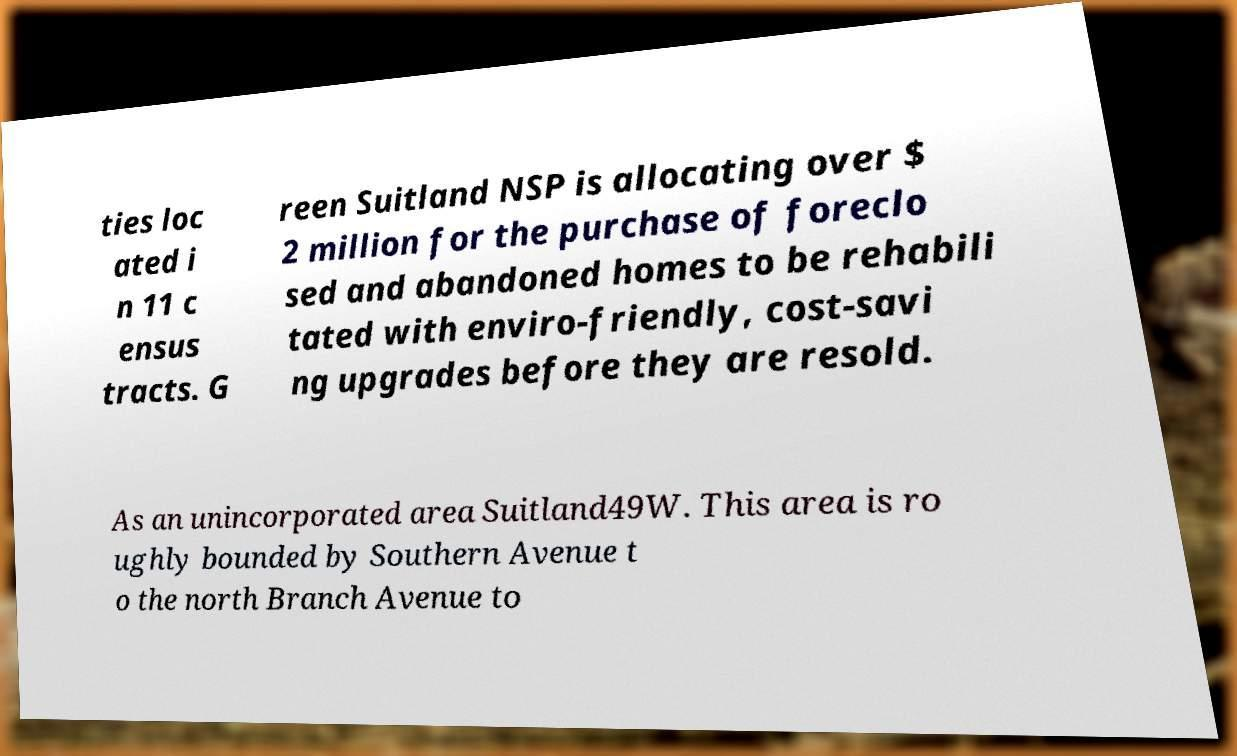Could you extract and type out the text from this image? ties loc ated i n 11 c ensus tracts. G reen Suitland NSP is allocating over $ 2 million for the purchase of foreclo sed and abandoned homes to be rehabili tated with enviro-friendly, cost-savi ng upgrades before they are resold. As an unincorporated area Suitland49W. This area is ro ughly bounded by Southern Avenue t o the north Branch Avenue to 